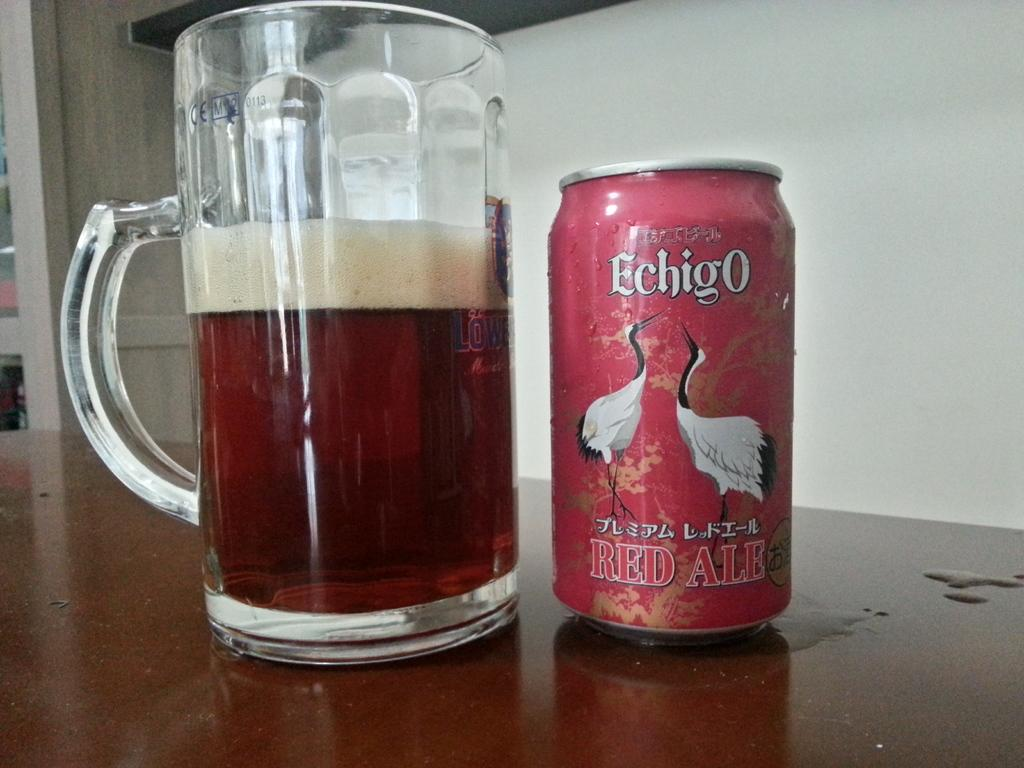<image>
Share a concise interpretation of the image provided. A red can of ale sits on a table next to a lager glass. 